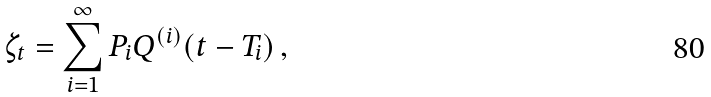Convert formula to latex. <formula><loc_0><loc_0><loc_500><loc_500>\zeta _ { t } = \sum _ { i = 1 } ^ { \infty } P _ { i } Q ^ { ( i ) } ( t - T _ { i } ) \, ,</formula> 